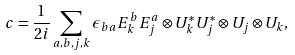Convert formula to latex. <formula><loc_0><loc_0><loc_500><loc_500>c = \frac { 1 } { 2 i } \sum _ { a , b , j , k } \epsilon _ { b a } E ^ { b } _ { k } E ^ { a } _ { j } \otimes U _ { k } ^ { * } U _ { j } ^ { * } \otimes U _ { j } \otimes U _ { k } ,</formula> 